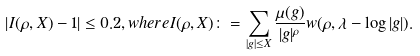Convert formula to latex. <formula><loc_0><loc_0><loc_500><loc_500>\left | I ( \rho , X ) - 1 \right | \leq 0 . 2 , w h e r e I ( \rho , X ) \colon = \sum _ { | g | \leq X } \frac { \mu ( g ) } { | g | ^ { \rho } } w ( \rho , \lambda - \log | g | ) .</formula> 